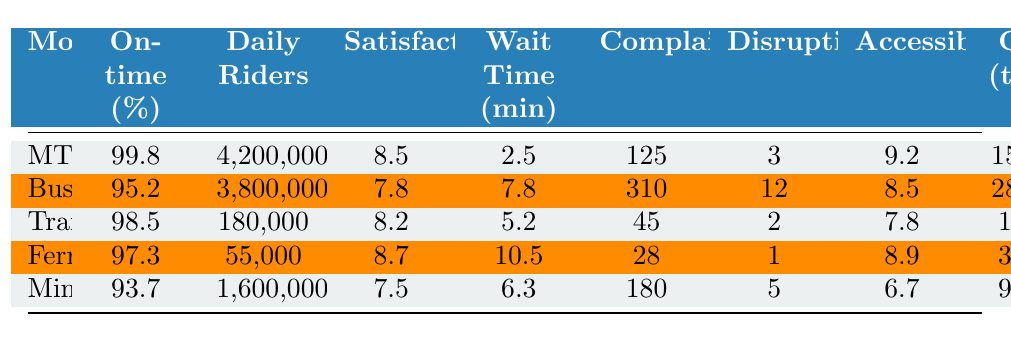What is the on-time performance percentage of the MTR? The MTR's on-time performance is listed directly in the table under the "On-time (%)" column for MTR, which is 99.8%.
Answer: 99.8% Which mode of transportation has the highest average daily ridership? Referring to the "Daily Riders" column, the MTR has the highest value at 4,200,000.
Answer: MTR What is the average customer satisfaction score for buses? The table provides the customer satisfaction score for buses, which is 7.8.
Answer: 7.8 How many complaints were received for the ferry service? The number of complaints for the ferry service is directly listed in the table under the "Complaints" column, which is 28.
Answer: 28 Which transportation mode has the lowest accessibility score? The accessibility score for each mode is provided in the table, and the minibus has the lowest score at 6.7, making it the answer.
Answer: Minibus What is the average wait time for trams? The average wait time for trams is found under the "Wait Time (min)" column, which shows 5.2 minutes.
Answer: 5.2 minutes Is the carbon emission of the bus service higher than that of the ferry service? By comparing the "CO2 (tons)" values, the bus has 28,500 tons while the ferry has 3,500 tons, indicating the bus emits more.
Answer: Yes What is the total number of complaints across all modes of transportation? Adding up the complaints: 125 + 310 + 45 + 28 + 180 gives a total of 688 complaints.
Answer: 688 Which public transportation mode has the highest fare? The fares are listed under "Fare (HKD)", and the MTR has the highest fare at 12.5 HKD.
Answer: MTR How does the average wait time of the minibus compare to that of the tram? The average wait time for the minibus is 6.3 minutes, whereas for the tram it's 5.2 minutes, indicating the minibus has a longer wait time.
Answer: Longer for minibus 